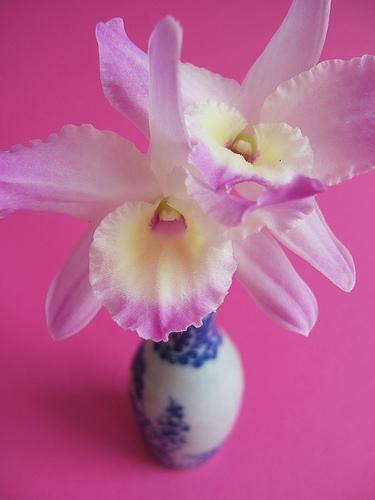How many are there?
Give a very brief answer. 2. How many flowers do you see?
Give a very brief answer. 2. How many vases are in the photo?
Give a very brief answer. 1. How many flowers are in the photo?
Give a very brief answer. 1. How many vases with patterns are in the photo?
Give a very brief answer. 1. How many orchids are in the vase?
Give a very brief answer. 2. How many orchids are seen?
Give a very brief answer. 2. 